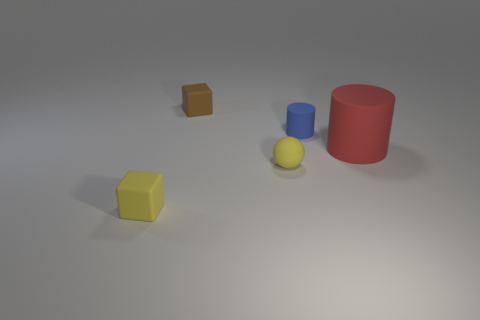Subtract all blue cylinders. How many cylinders are left? 1 Add 3 balls. How many objects exist? 8 Subtract 0 purple blocks. How many objects are left? 5 Subtract all blocks. How many objects are left? 3 Subtract 1 cubes. How many cubes are left? 1 Subtract all purple balls. Subtract all yellow blocks. How many balls are left? 1 Subtract all cyan balls. How many green cylinders are left? 0 Subtract all big gray cylinders. Subtract all rubber objects. How many objects are left? 0 Add 1 yellow cubes. How many yellow cubes are left? 2 Add 1 large brown shiny blocks. How many large brown shiny blocks exist? 1 